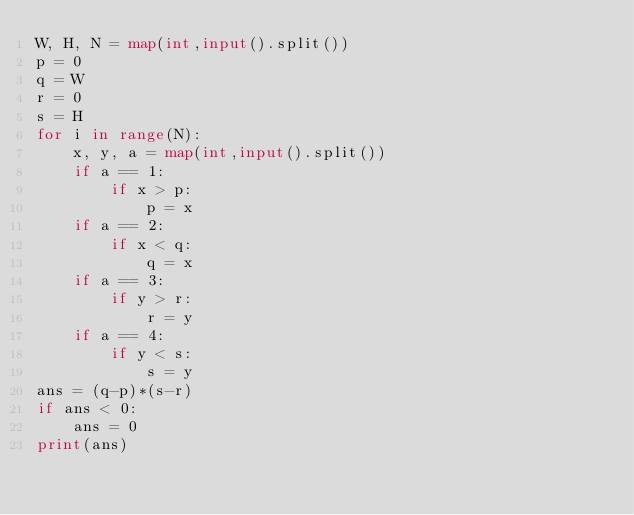<code> <loc_0><loc_0><loc_500><loc_500><_Python_>W, H, N = map(int,input().split())
p = 0
q = W
r = 0
s = H
for i in range(N):
    x, y, a = map(int,input().split())
    if a == 1:
        if x > p:
            p = x
    if a == 2:
        if x < q:
            q = x
    if a == 3:
        if y > r:
            r = y
    if a == 4:
        if y < s:
            s = y
ans = (q-p)*(s-r)
if ans < 0:
    ans = 0
print(ans)</code> 